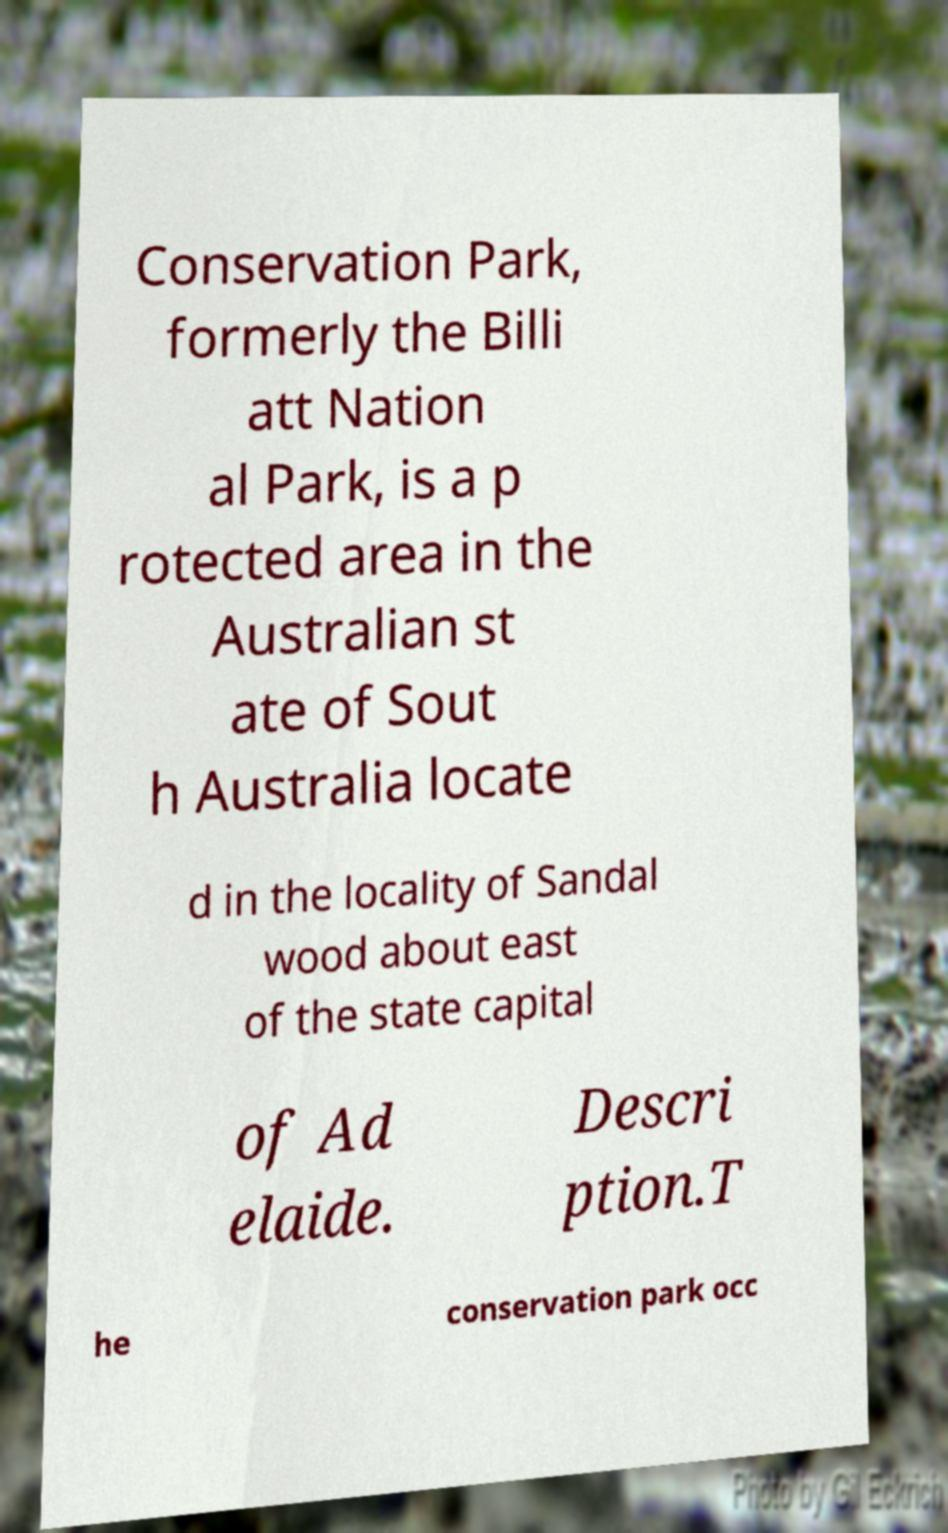Please identify and transcribe the text found in this image. Conservation Park, formerly the Billi att Nation al Park, is a p rotected area in the Australian st ate of Sout h Australia locate d in the locality of Sandal wood about east of the state capital of Ad elaide. Descri ption.T he conservation park occ 